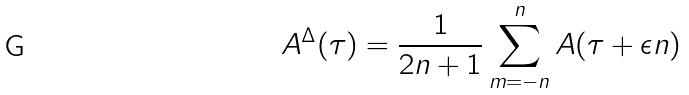<formula> <loc_0><loc_0><loc_500><loc_500>A ^ { \Delta } ( \tau ) = \frac { 1 } { 2 n + 1 } \sum _ { m = - n } ^ { n } A ( \tau + \epsilon n )</formula> 